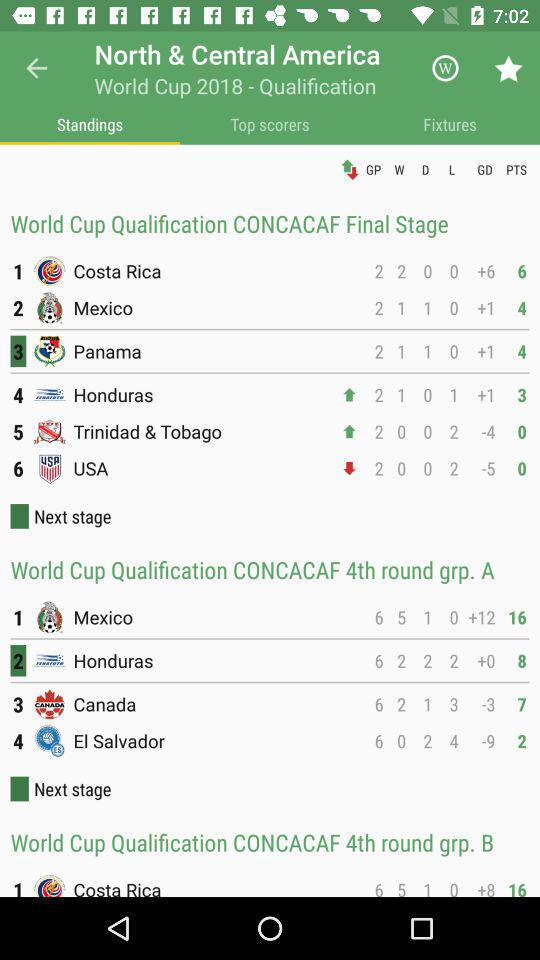What is the total number of draw matches played by "Honduras" in the "CONCACAF 4th round grp. A"? The total number of draw matches played by "Honduras" in the "CONCACAF 4th round grp. A" is 2. 